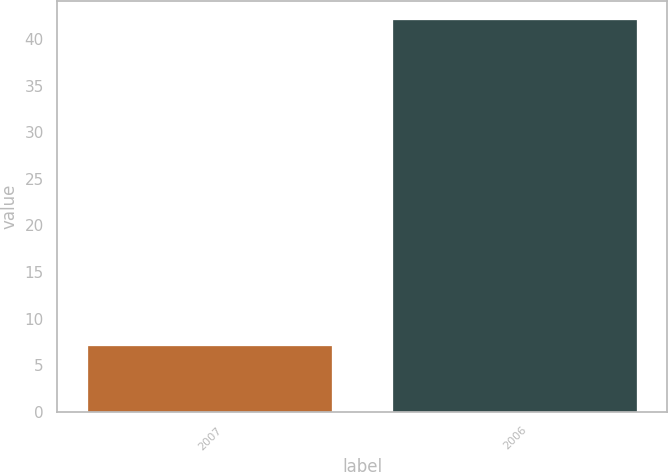Convert chart to OTSL. <chart><loc_0><loc_0><loc_500><loc_500><bar_chart><fcel>2007<fcel>2006<nl><fcel>7<fcel>42<nl></chart> 